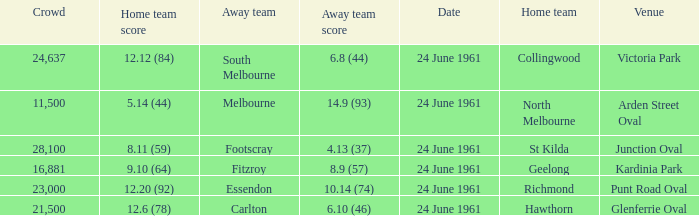Who was the home team that scored 12.6 (78)? Hawthorn. 